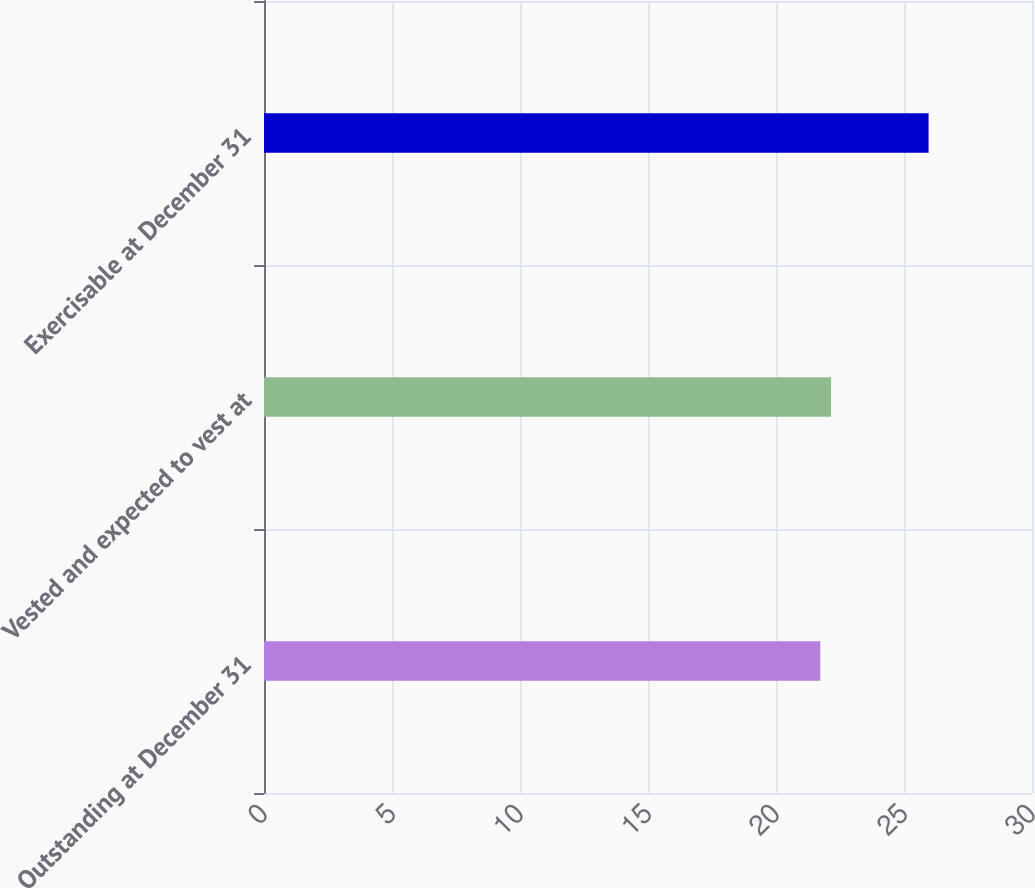Convert chart. <chart><loc_0><loc_0><loc_500><loc_500><bar_chart><fcel>Outstanding at December 31<fcel>Vested and expected to vest at<fcel>Exercisable at December 31<nl><fcel>21.73<fcel>22.15<fcel>25.96<nl></chart> 